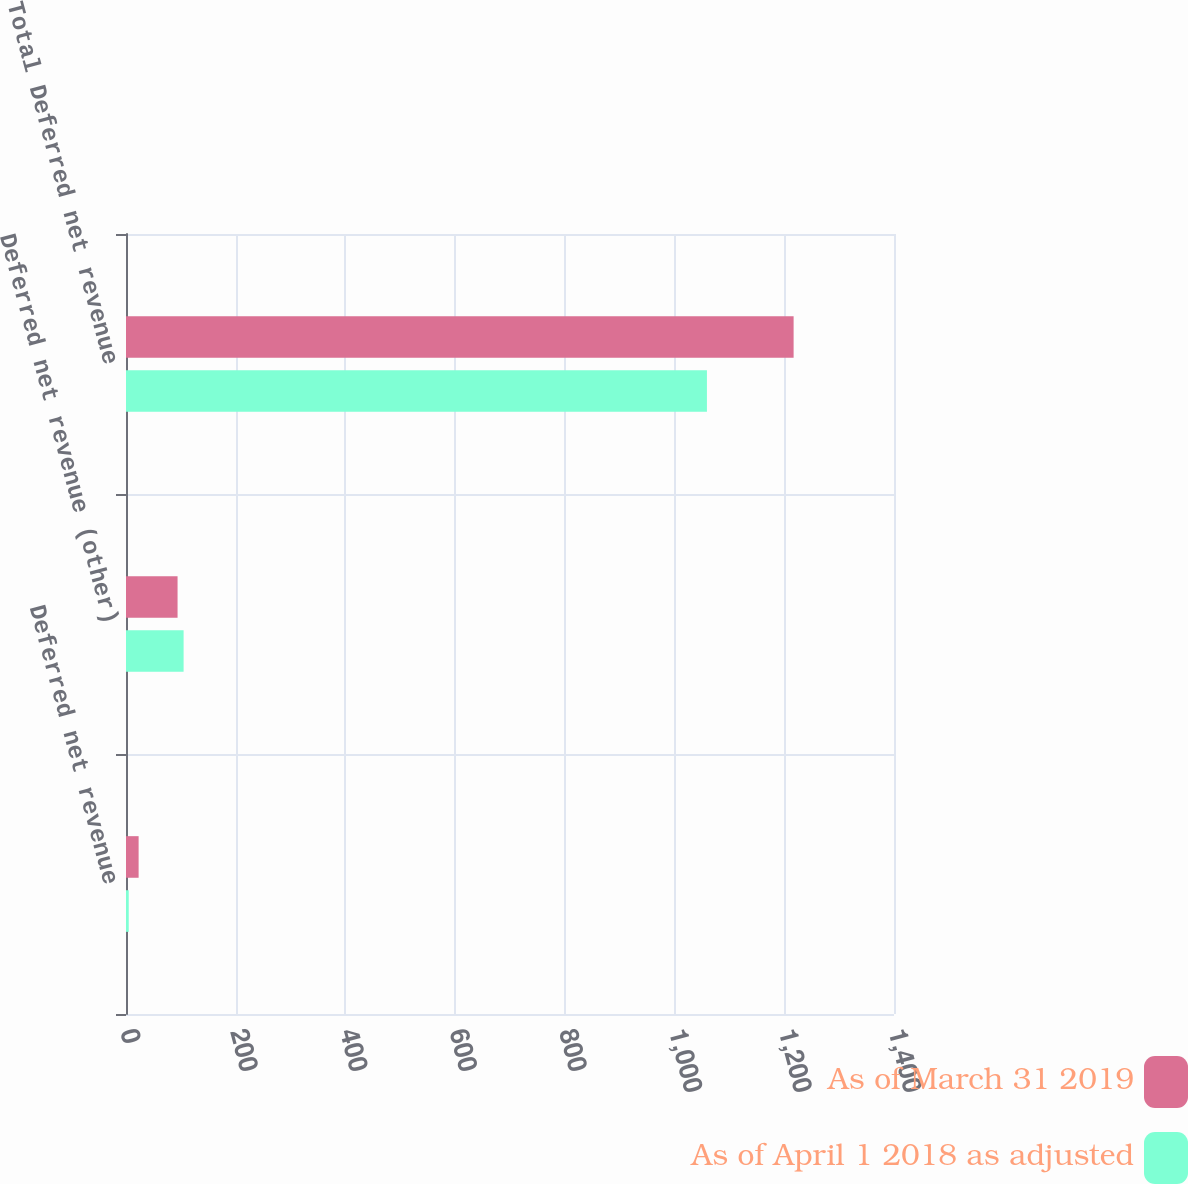<chart> <loc_0><loc_0><loc_500><loc_500><stacked_bar_chart><ecel><fcel>Deferred net revenue<fcel>Deferred net revenue (other)<fcel>Total Deferred net revenue<nl><fcel>As of March 31 2019<fcel>23<fcel>94<fcel>1217<nl><fcel>As of April 1 2018 as adjusted<fcel>5<fcel>105<fcel>1059<nl></chart> 